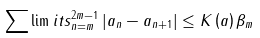Convert formula to latex. <formula><loc_0><loc_0><loc_500><loc_500>\sum \lim i t s _ { n = m } ^ { 2 m - 1 } \left | a _ { n } - a _ { n + 1 } \right | \leq K \left ( a \right ) \beta _ { m }</formula> 